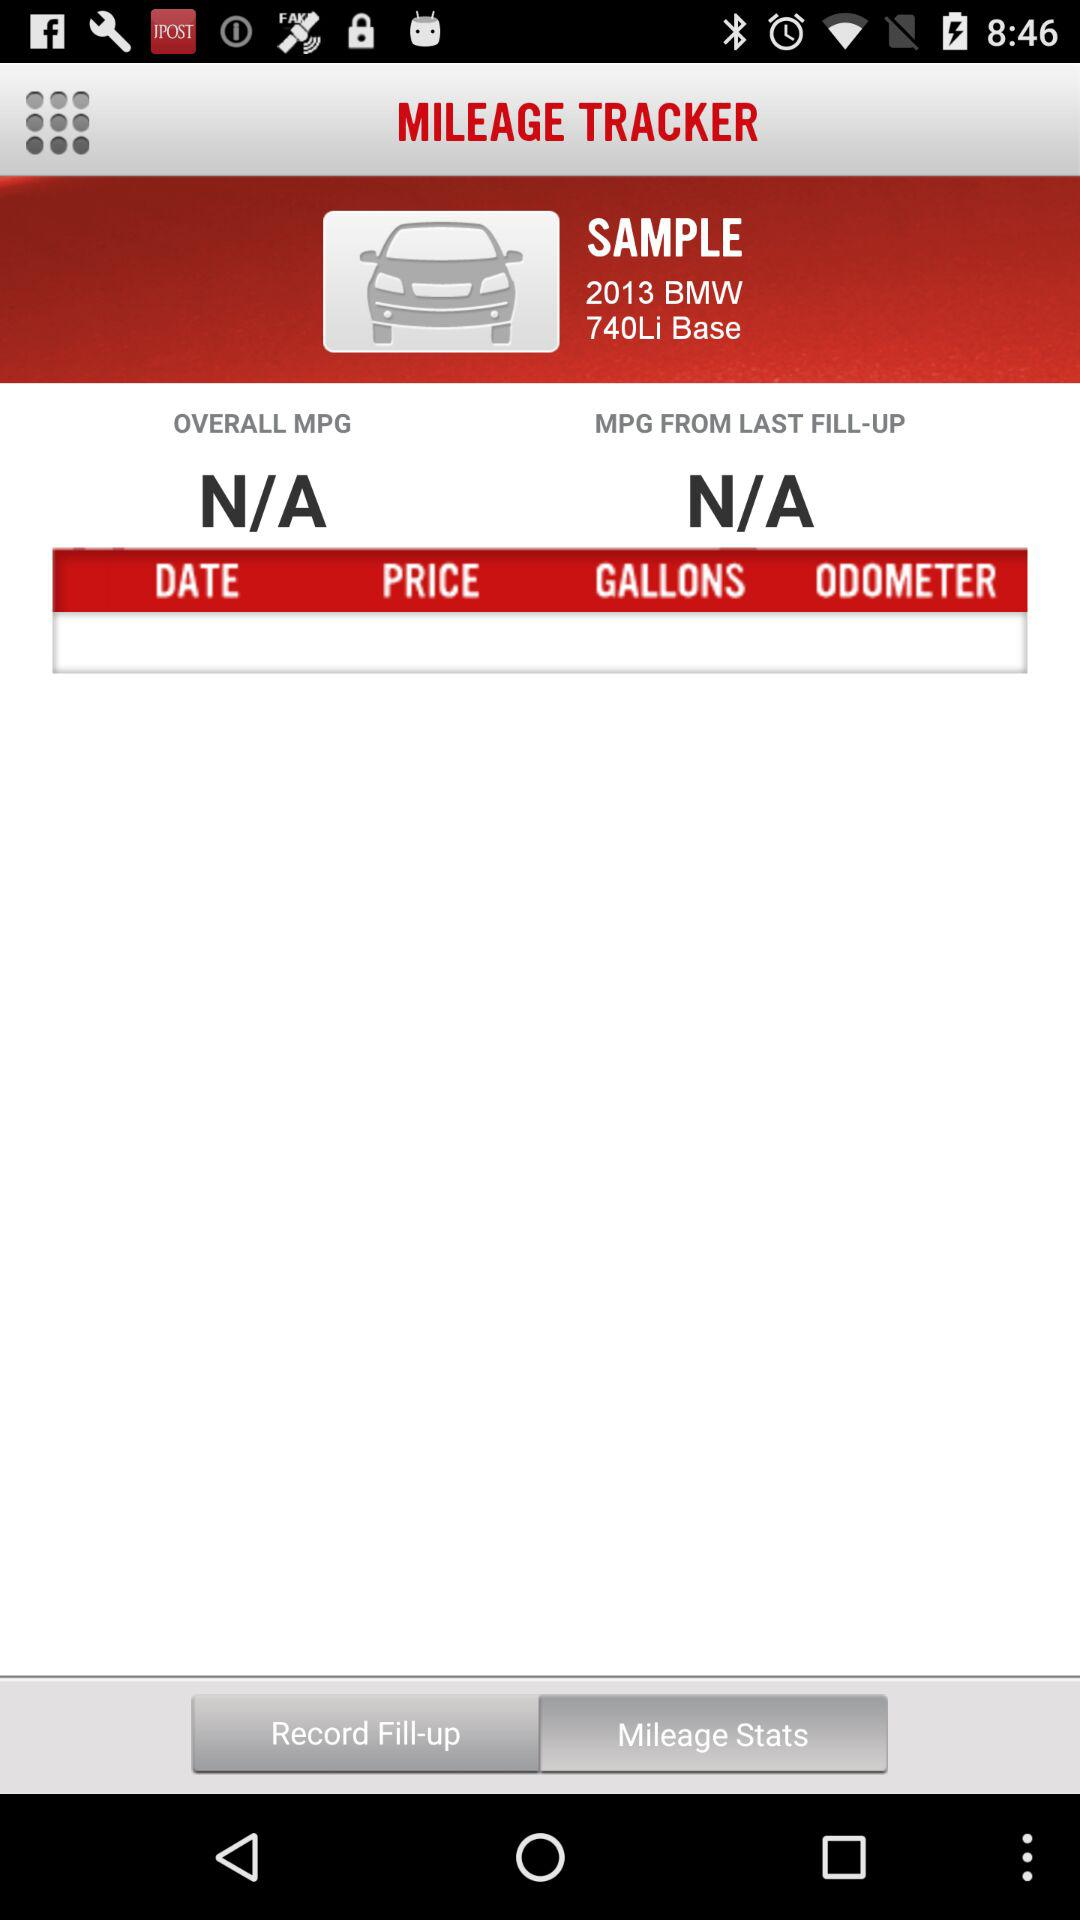What is the overall MPG? The overall MPG is N/A. 